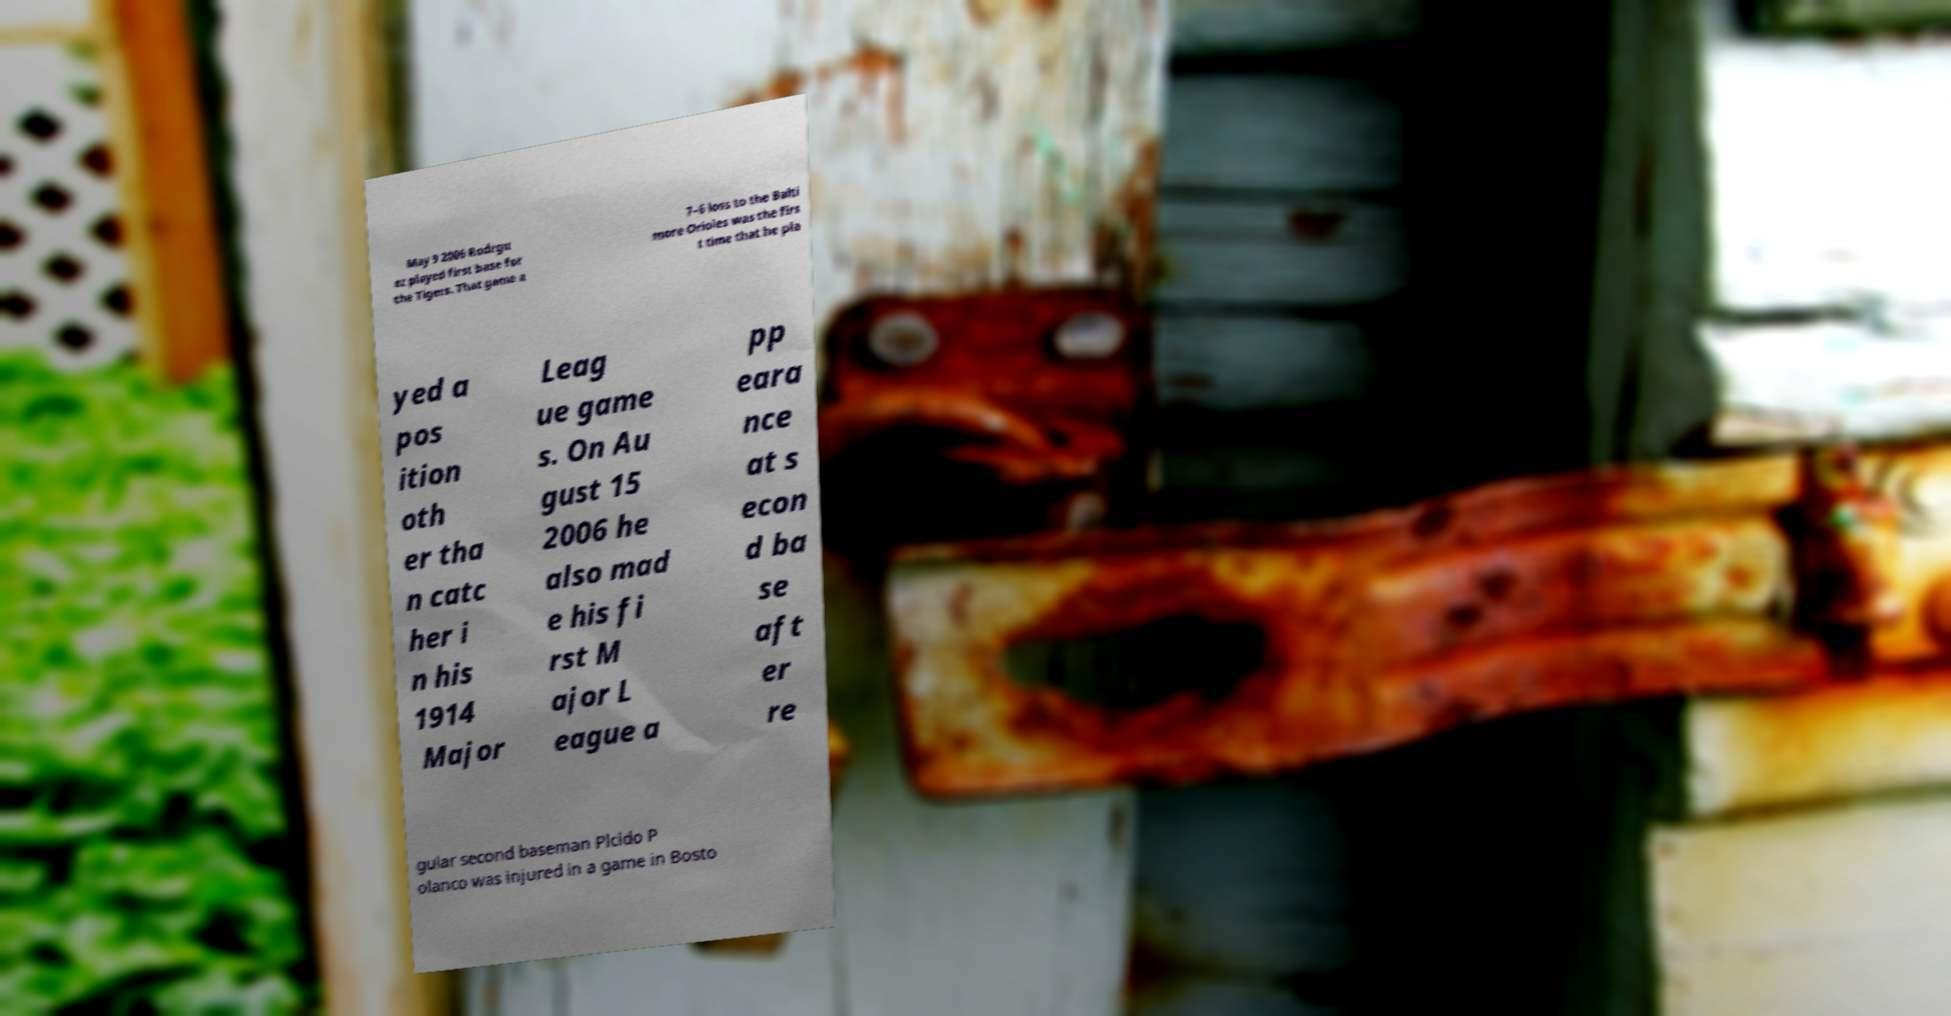What messages or text are displayed in this image? I need them in a readable, typed format. May 9 2006 Rodrgu ez played first base for the Tigers. That game a 7–6 loss to the Balti more Orioles was the firs t time that he pla yed a pos ition oth er tha n catc her i n his 1914 Major Leag ue game s. On Au gust 15 2006 he also mad e his fi rst M ajor L eague a pp eara nce at s econ d ba se aft er re gular second baseman Plcido P olanco was injured in a game in Bosto 